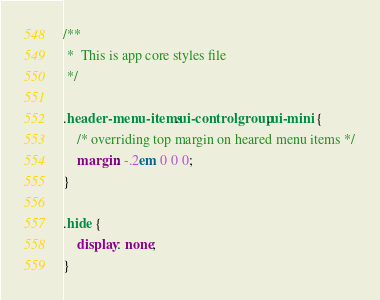<code> <loc_0><loc_0><loc_500><loc_500><_CSS_>/**
 * 	This is app core styles file
 */

.header-menu-items.ui-controlgroup.ui-mini {
    /* overriding top margin on heared menu items */
    margin: -.2em 0 0 0;
}

.hide {
	display: none;
}
</code> 